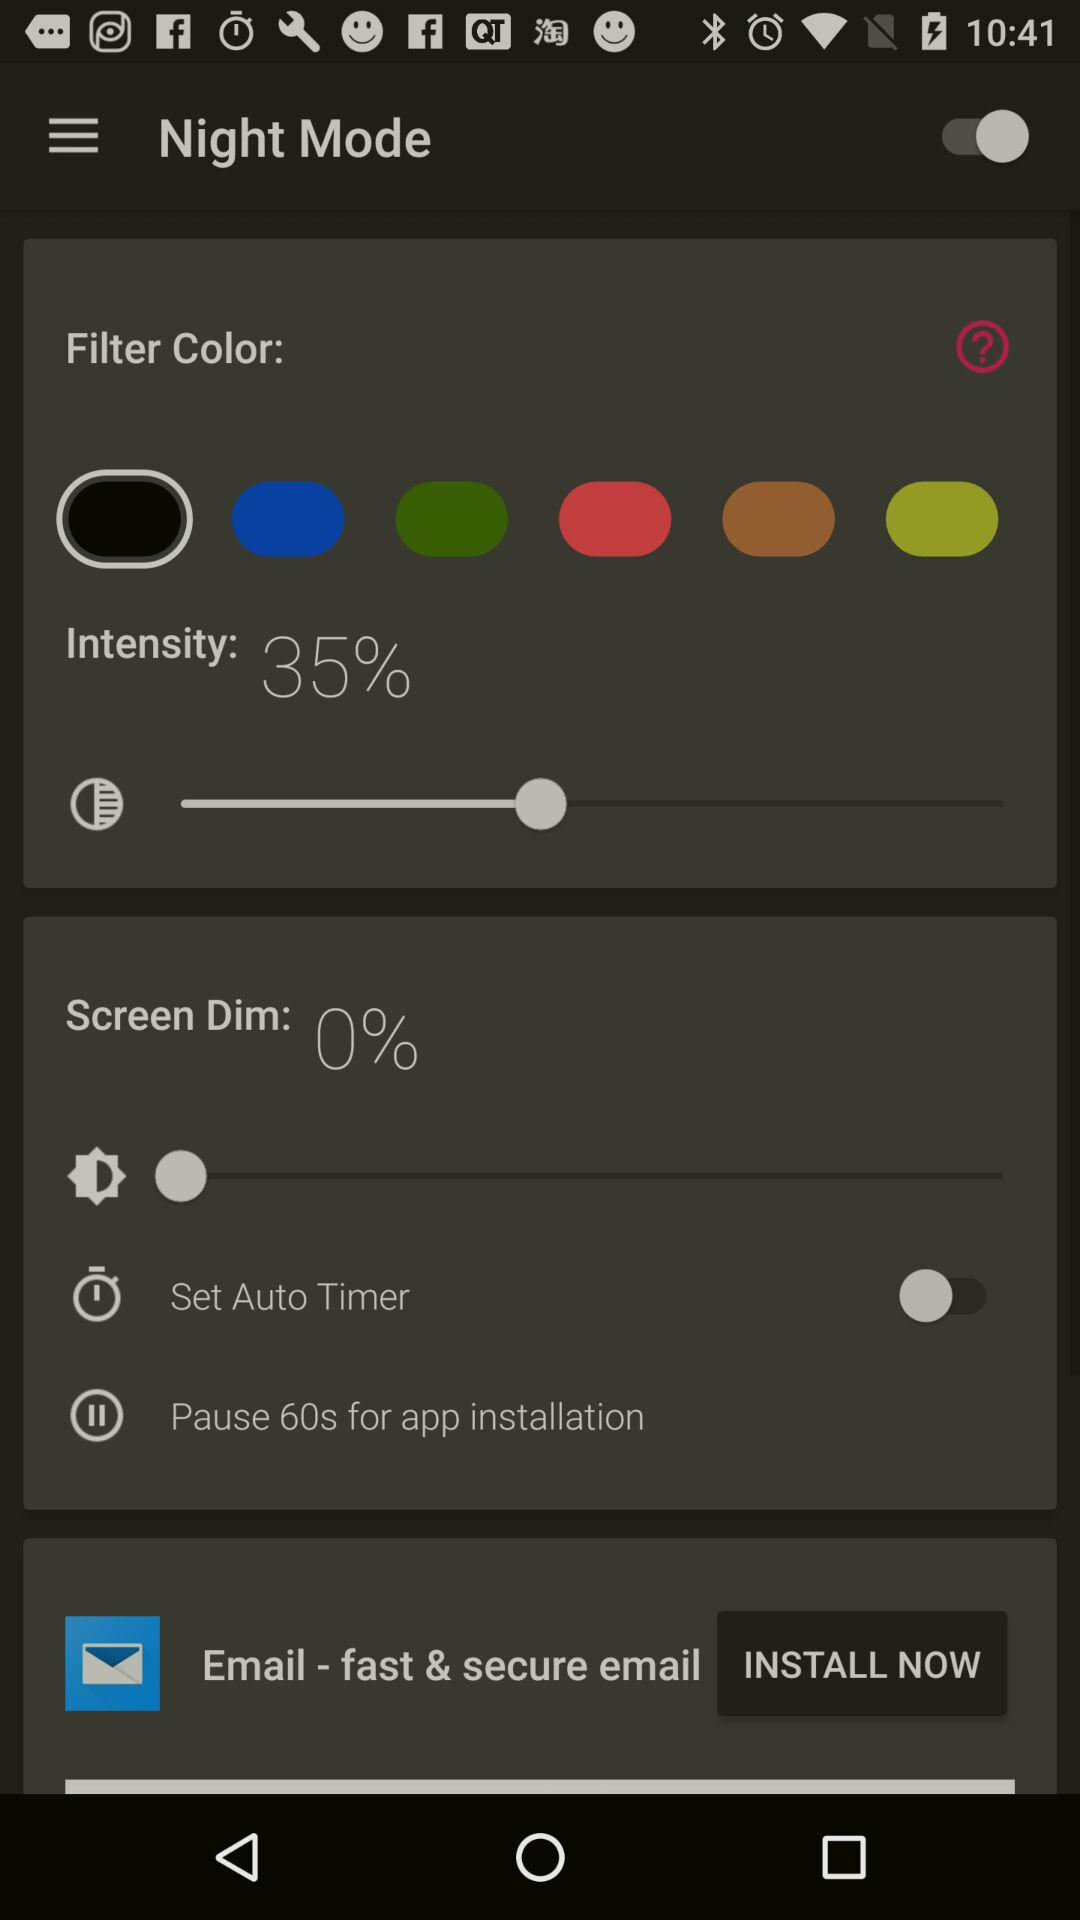What is the percentage of "Screen Dim"? The percentage of "Screen Dim" is 0. 